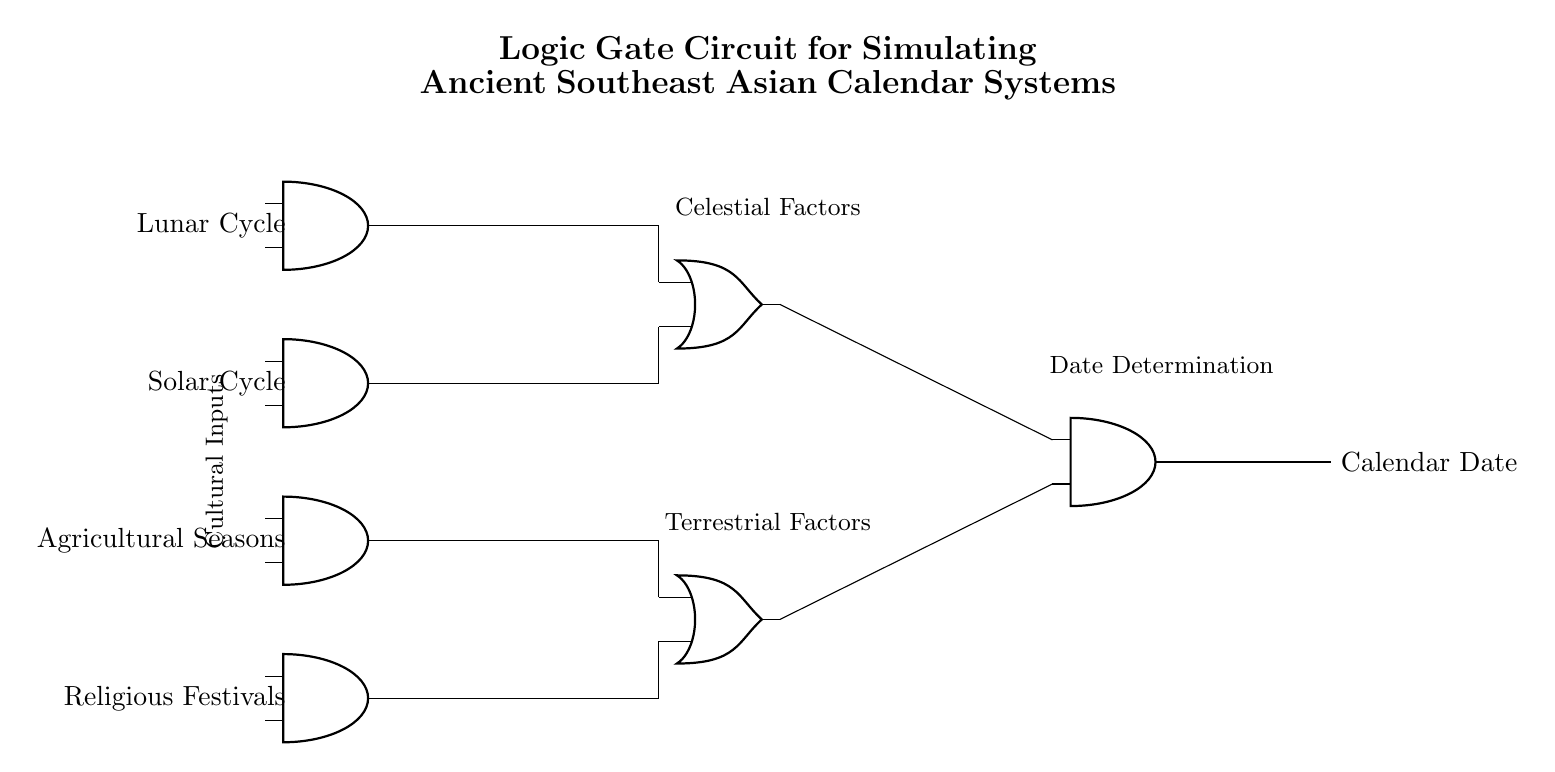What are the inputs to the logic gate circuit? The inputs are the Lunar Cycle, Solar Cycle, Agricultural Seasons, and Religious Festivals, clearly labeled on the left side of the circuit.
Answer: Lunar Cycle, Solar Cycle, Agricultural Seasons, Religious Festivals How many AND gates are present in the circuit? Counting the AND gates shown in the diagram, there are a total of four AND gates indicated.
Answer: Four What is the output of the logic gate circuit? The output is labeled as Calendar Date, which is the final result produced by the logic gate configuration.
Answer: Calendar Date Which types of factors are represented in the circuit? The circuit differentiates between Celestial factors, which include the Lunar and Solar Cycles, and Terrestrial factors, which encompass Agricultural Seasons and Religious Festivals.
Answer: Celestial and Terrestrial What is the role of the OR gate in this circuit? The OR gates combine outputs from the AND gates to determine collective influences on the Calendar Date, integrating both celestial and terrestrial factors.
Answer: Combining outputs Explain how the Calendar Date is determined in the circuit. The determination of the Calendar Date involves firstly processing inputs through the AND gates for specific factors, passing them to the OR gates to evaluate conditions collectively, and finally feeding the combined results into the final AND gate for output. This sequential logic simulates interactions influencing ancient calendar systems.
Answer: Sequential logic of factors Which cultural aspects are considered in this logic gate circuit? The circuit considers cultural aspects related to agricultural seasons and religious festivals in conjunction with celestial cycles, showcasing the integration of these elements in calendar simulation.
Answer: Agricultural seasons and religious festivals 